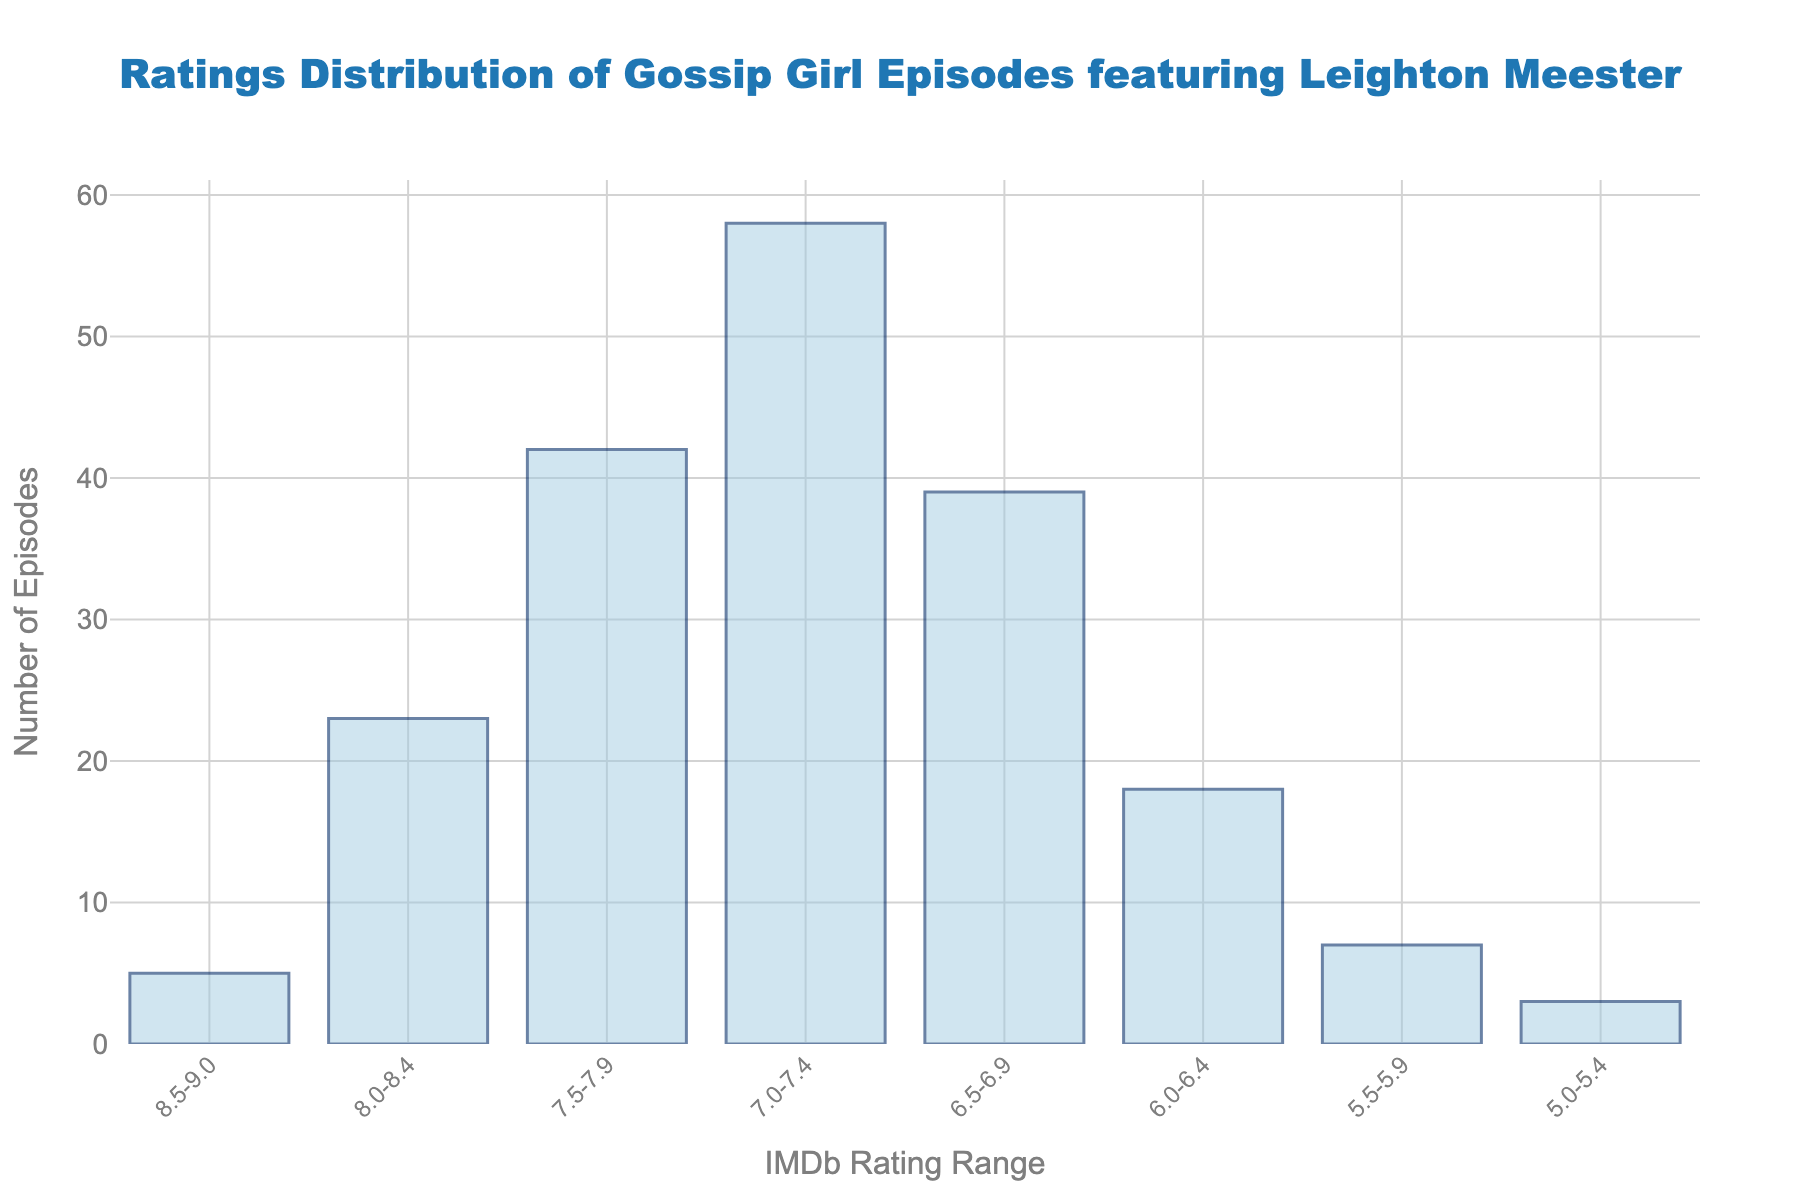What's the highest number of episodes in any rating range? The highest bar on the chart is for the 7.0-7.4 rating range, indicating the most episodes in this category. Looking at the y-axis, we see that this bar corresponds to 58 episodes.
Answer: 58 Which rating range has the least number of episodes? The shortest bar on the chart indicates the rating range with the least number of episodes. This is the 5.0-5.4 rating range, which has 3 episodes.
Answer: 3 How many more episodes are in the 7.0-7.4 range compared to the 8.0-8.4 range? To find the difference, subtract the number of episodes in the 8.0-8.4 range (23) from the number of episodes in the 7.0-7.4 range (58). Calculation: 58 - 23 = 35.
Answer: 35 What is the total number of episodes in the 6.0-6.4 and 6.5-6.9 rating ranges combined? Sum the number of episodes in the two rating ranges by adding 18 (6.0-6.4 range) and 39 (6.5-6.9 range). Calculation: 18 + 39 = 57.
Answer: 57 Which rating range has more episodes, 8.5-9.0 or 5.5-5.9, and by how many? Compare the number of episodes in the 8.5-9.0 range (5) with those in the 5.5-5.9 range (7). Since 5 < 7, calculate the difference: 7 - 5 = 2.
Answer: 5.5-5.9 by 2 What's the combined total of episodes in rating ranges that start with 7.x? Sum up the number of episodes in the 7.0-7.4 (58) and 7.5-7.9 (42) ranges. Calculation: 58 + 42 = 100.
Answer: 100 